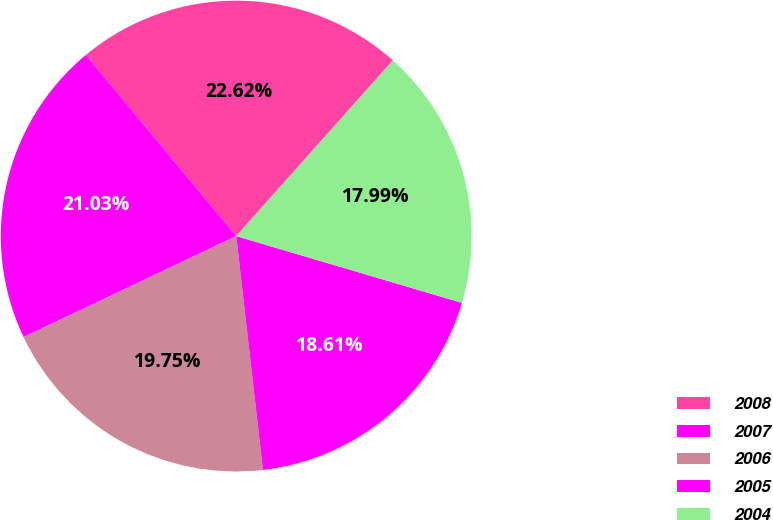<chart> <loc_0><loc_0><loc_500><loc_500><pie_chart><fcel>2008<fcel>2007<fcel>2006<fcel>2005<fcel>2004<nl><fcel>22.62%<fcel>21.03%<fcel>19.75%<fcel>18.61%<fcel>17.99%<nl></chart> 